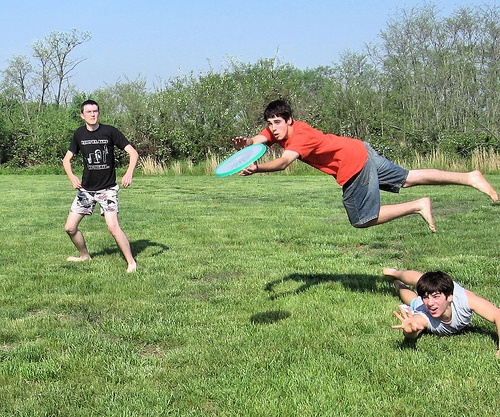Describe the objects in this image and their specific colors. I can see people in lightblue, salmon, gray, black, and lightgray tones, people in lightblue, black, lightgray, gray, and olive tones, people in lightblue, black, tan, and lightgray tones, and frisbee in lightblue, turquoise, and aquamarine tones in this image. 